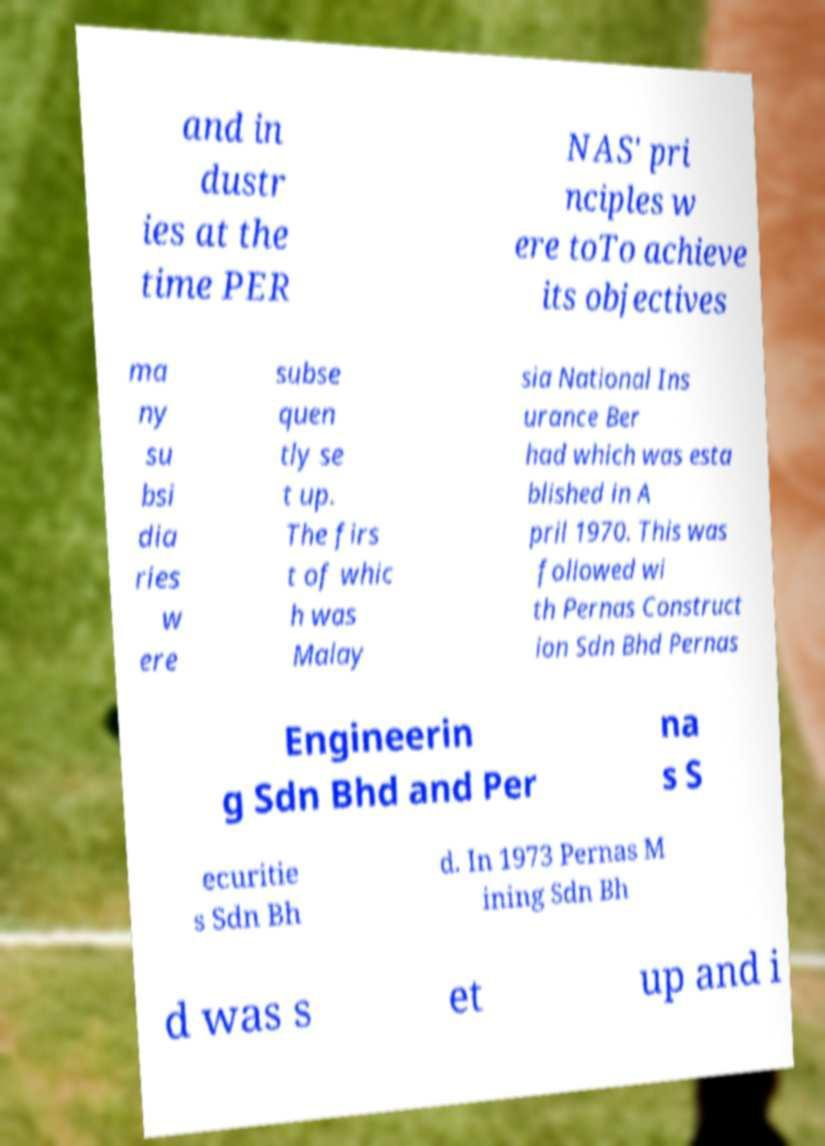What messages or text are displayed in this image? I need them in a readable, typed format. and in dustr ies at the time PER NAS' pri nciples w ere toTo achieve its objectives ma ny su bsi dia ries w ere subse quen tly se t up. The firs t of whic h was Malay sia National Ins urance Ber had which was esta blished in A pril 1970. This was followed wi th Pernas Construct ion Sdn Bhd Pernas Engineerin g Sdn Bhd and Per na s S ecuritie s Sdn Bh d. In 1973 Pernas M ining Sdn Bh d was s et up and i 